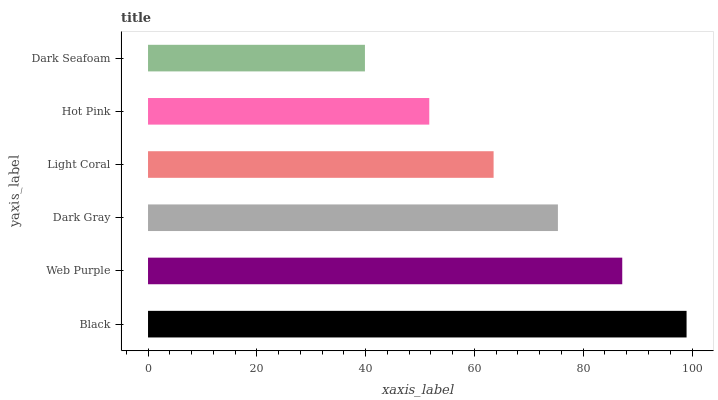Is Dark Seafoam the minimum?
Answer yes or no. Yes. Is Black the maximum?
Answer yes or no. Yes. Is Web Purple the minimum?
Answer yes or no. No. Is Web Purple the maximum?
Answer yes or no. No. Is Black greater than Web Purple?
Answer yes or no. Yes. Is Web Purple less than Black?
Answer yes or no. Yes. Is Web Purple greater than Black?
Answer yes or no. No. Is Black less than Web Purple?
Answer yes or no. No. Is Dark Gray the high median?
Answer yes or no. Yes. Is Light Coral the low median?
Answer yes or no. Yes. Is Web Purple the high median?
Answer yes or no. No. Is Web Purple the low median?
Answer yes or no. No. 